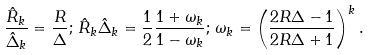Convert formula to latex. <formula><loc_0><loc_0><loc_500><loc_500>\frac { \hat { R } _ { k } } { \hat { \Delta } _ { k } } = \frac { R } { \Delta } ; \, \hat { R } _ { k } \hat { \Delta } _ { k } = \frac { 1 } { 2 } \frac { 1 + \omega _ { k } } { 1 - \omega _ { k } } ; \, \omega _ { k } = \left ( \frac { 2 R \Delta - 1 } { 2 R \Delta + 1 } \right ) ^ { k } .</formula> 